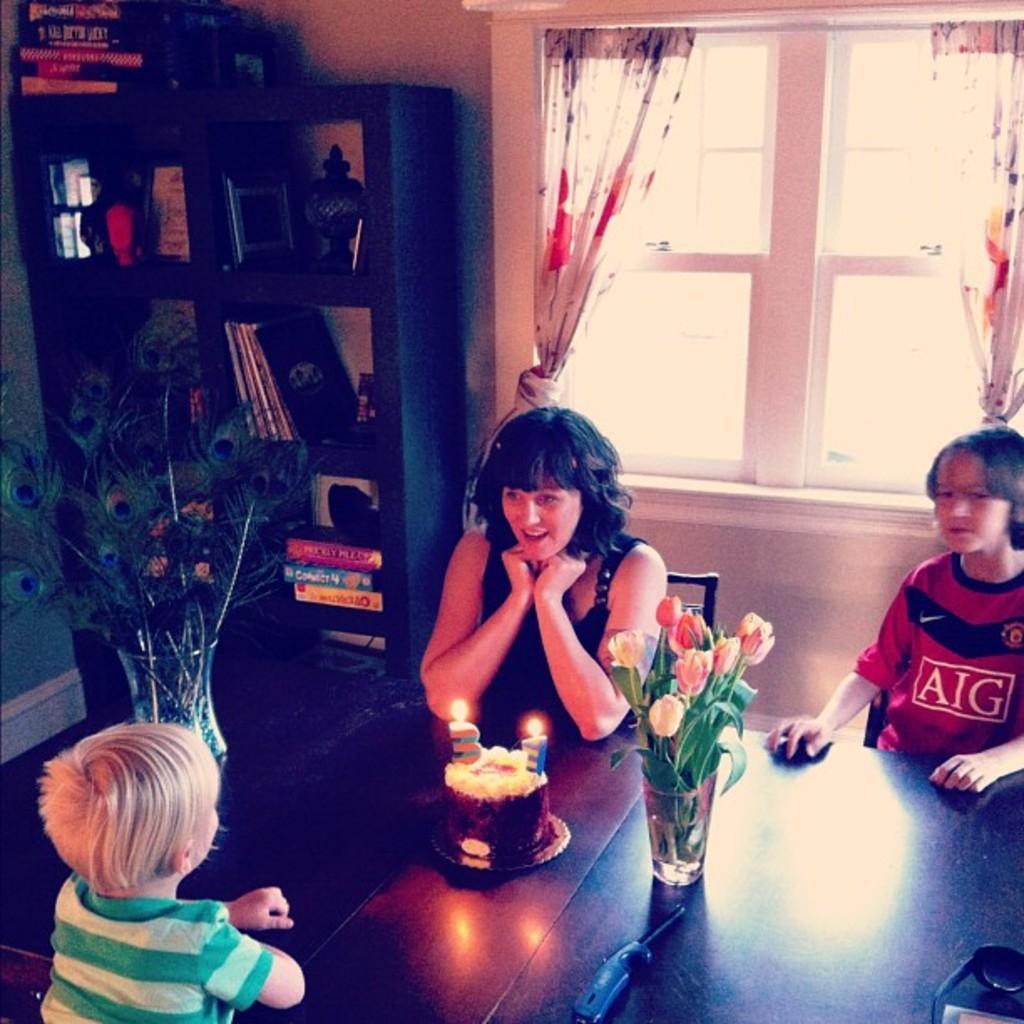In one or two sentences, can you explain what this image depicts? A lady wearing a black dress is sitting on a chair. And also two children wearing red and green dress is sitting on chair. In front of them there is a table. On the table there are two vases, cake with candles, On one vase there are flowers, and on another vase there are peacock feathers. In the background there is a window with curtains, a cupboard. Inside the cupboard there are books. 